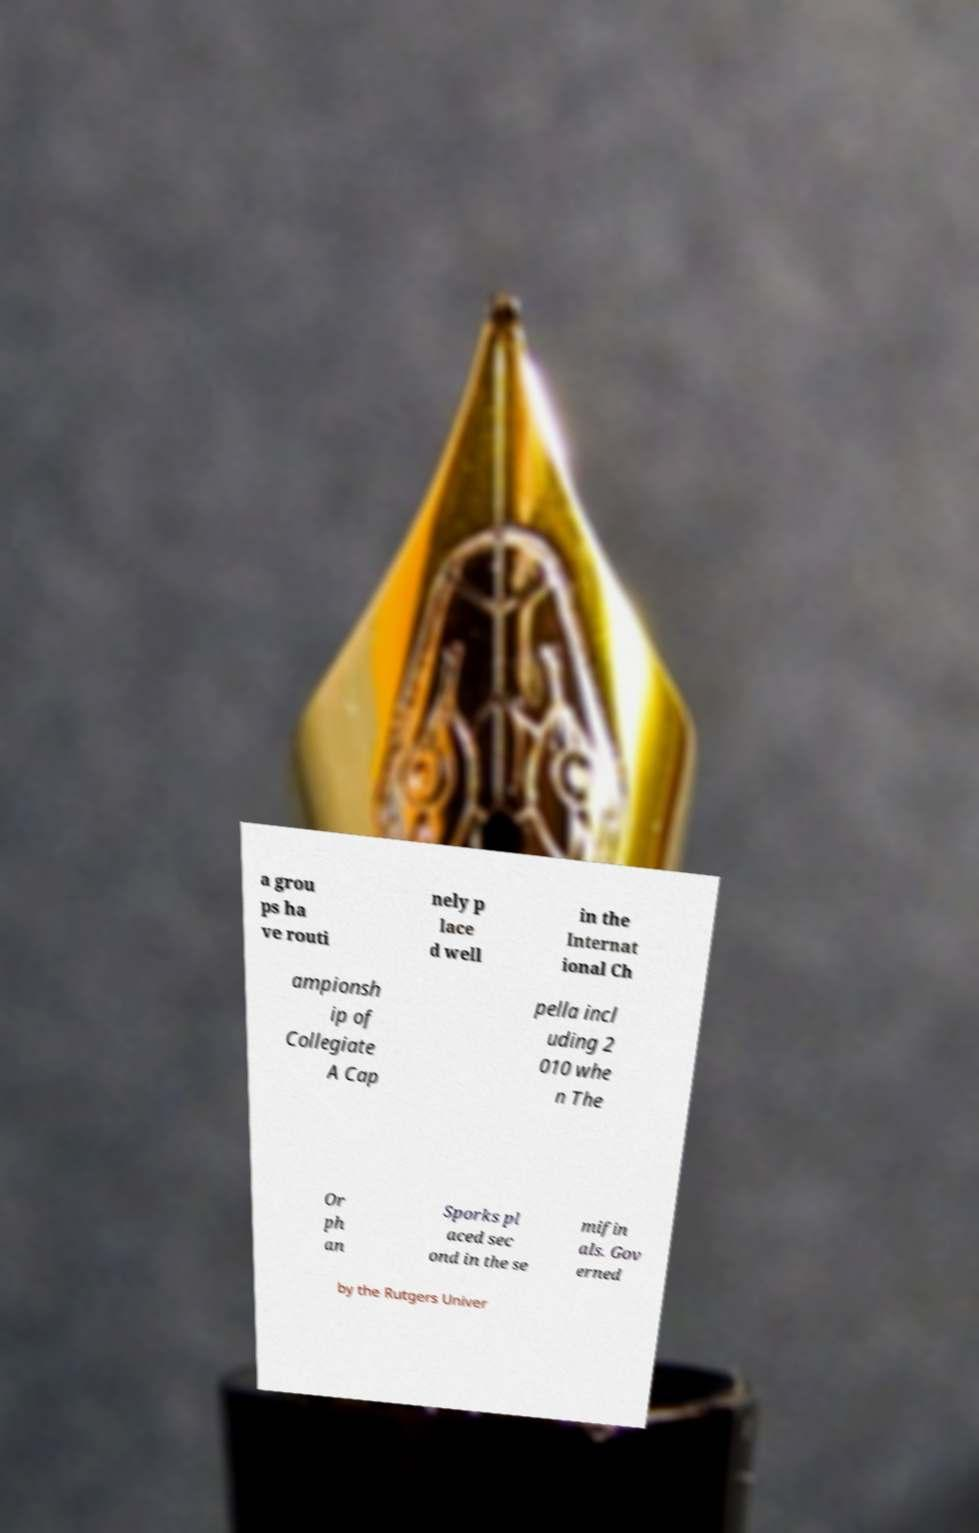I need the written content from this picture converted into text. Can you do that? a grou ps ha ve routi nely p lace d well in the Internat ional Ch ampionsh ip of Collegiate A Cap pella incl uding 2 010 whe n The Or ph an Sporks pl aced sec ond in the se mifin als. Gov erned by the Rutgers Univer 